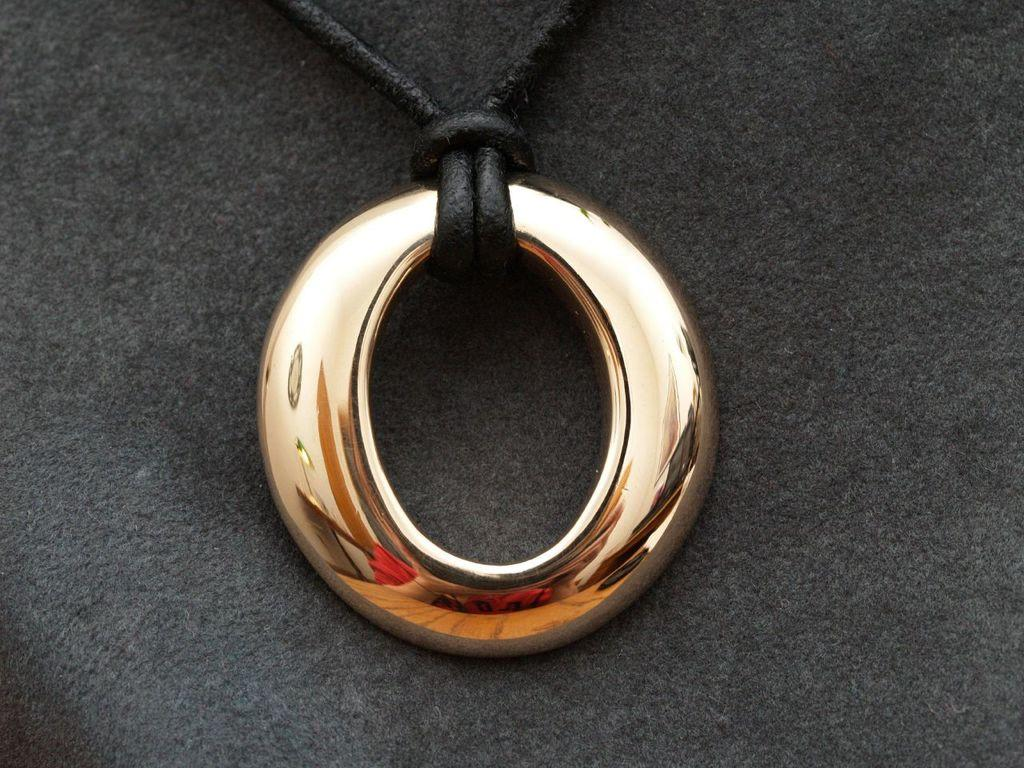What type of jewelry is visible in the image? There is a golden necklace in the image. What is the color of the cloth on which the necklace is placed? The golden necklace is placed on a black cloth. How does the necklace pull objects in space in the image? The image does not depict any objects in space, nor does it show the necklace having any effect on objects. 